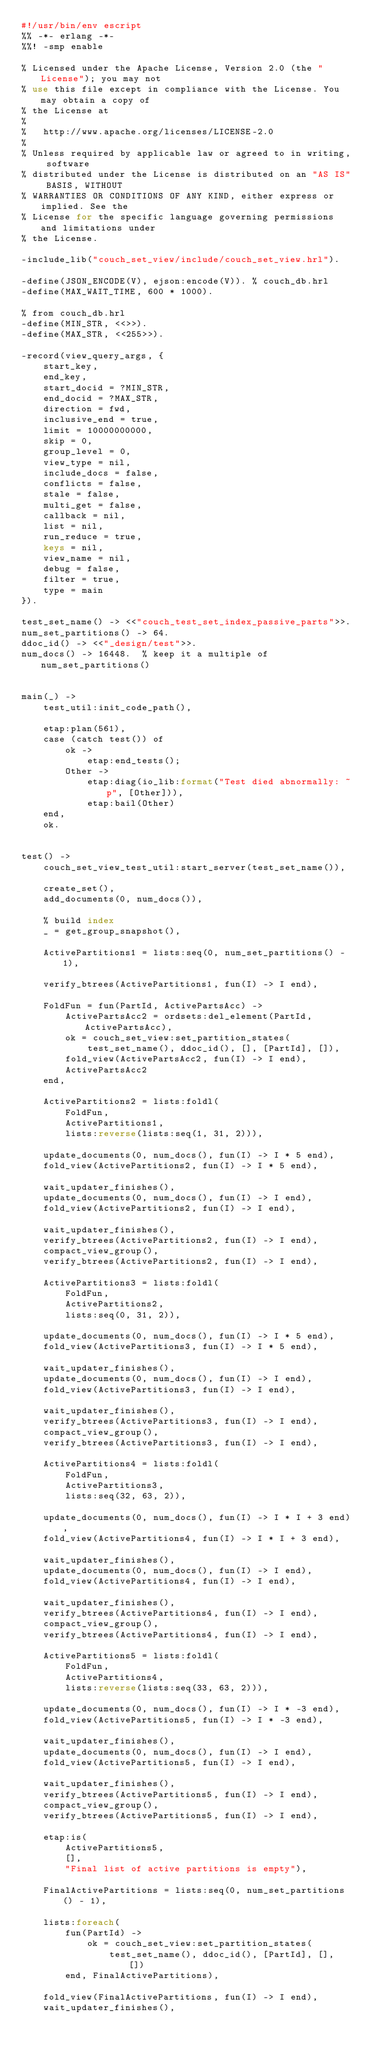<code> <loc_0><loc_0><loc_500><loc_500><_Perl_>#!/usr/bin/env escript
%% -*- erlang -*-
%%! -smp enable

% Licensed under the Apache License, Version 2.0 (the "License"); you may not
% use this file except in compliance with the License. You may obtain a copy of
% the License at
%
%   http://www.apache.org/licenses/LICENSE-2.0
%
% Unless required by applicable law or agreed to in writing, software
% distributed under the License is distributed on an "AS IS" BASIS, WITHOUT
% WARRANTIES OR CONDITIONS OF ANY KIND, either express or implied. See the
% License for the specific language governing permissions and limitations under
% the License.

-include_lib("couch_set_view/include/couch_set_view.hrl").

-define(JSON_ENCODE(V), ejson:encode(V)). % couch_db.hrl
-define(MAX_WAIT_TIME, 600 * 1000).

% from couch_db.hrl
-define(MIN_STR, <<>>).
-define(MAX_STR, <<255>>).

-record(view_query_args, {
    start_key,
    end_key,
    start_docid = ?MIN_STR,
    end_docid = ?MAX_STR,
    direction = fwd,
    inclusive_end = true,
    limit = 10000000000,
    skip = 0,
    group_level = 0,
    view_type = nil,
    include_docs = false,
    conflicts = false,
    stale = false,
    multi_get = false,
    callback = nil,
    list = nil,
    run_reduce = true,
    keys = nil,
    view_name = nil,
    debug = false,
    filter = true,
    type = main
}).

test_set_name() -> <<"couch_test_set_index_passive_parts">>.
num_set_partitions() -> 64.
ddoc_id() -> <<"_design/test">>.
num_docs() -> 16448.  % keep it a multiple of num_set_partitions()


main(_) ->
    test_util:init_code_path(),

    etap:plan(561),
    case (catch test()) of
        ok ->
            etap:end_tests();
        Other ->
            etap:diag(io_lib:format("Test died abnormally: ~p", [Other])),
            etap:bail(Other)
    end,
    ok.


test() ->
    couch_set_view_test_util:start_server(test_set_name()),

    create_set(),
    add_documents(0, num_docs()),

    % build index
    _ = get_group_snapshot(),

    ActivePartitions1 = lists:seq(0, num_set_partitions() - 1),

    verify_btrees(ActivePartitions1, fun(I) -> I end),

    FoldFun = fun(PartId, ActivePartsAcc) ->
        ActivePartsAcc2 = ordsets:del_element(PartId, ActivePartsAcc),
        ok = couch_set_view:set_partition_states(
            test_set_name(), ddoc_id(), [], [PartId], []),
        fold_view(ActivePartsAcc2, fun(I) -> I end),
        ActivePartsAcc2
    end,

    ActivePartitions2 = lists:foldl(
        FoldFun,
        ActivePartitions1,
        lists:reverse(lists:seq(1, 31, 2))),

    update_documents(0, num_docs(), fun(I) -> I * 5 end),
    fold_view(ActivePartitions2, fun(I) -> I * 5 end),

    wait_updater_finishes(),
    update_documents(0, num_docs(), fun(I) -> I end),
    fold_view(ActivePartitions2, fun(I) -> I end),

    wait_updater_finishes(),
    verify_btrees(ActivePartitions2, fun(I) -> I end),
    compact_view_group(),
    verify_btrees(ActivePartitions2, fun(I) -> I end),

    ActivePartitions3 = lists:foldl(
        FoldFun,
        ActivePartitions2,
        lists:seq(0, 31, 2)),

    update_documents(0, num_docs(), fun(I) -> I * 5 end),
    fold_view(ActivePartitions3, fun(I) -> I * 5 end),

    wait_updater_finishes(),
    update_documents(0, num_docs(), fun(I) -> I end),
    fold_view(ActivePartitions3, fun(I) -> I end),

    wait_updater_finishes(),
    verify_btrees(ActivePartitions3, fun(I) -> I end),
    compact_view_group(),
    verify_btrees(ActivePartitions3, fun(I) -> I end),

    ActivePartitions4 = lists:foldl(
        FoldFun,
        ActivePartitions3,
        lists:seq(32, 63, 2)),

    update_documents(0, num_docs(), fun(I) -> I * I + 3 end),
    fold_view(ActivePartitions4, fun(I) -> I * I + 3 end),

    wait_updater_finishes(),
    update_documents(0, num_docs(), fun(I) -> I end),
    fold_view(ActivePartitions4, fun(I) -> I end),

    wait_updater_finishes(),
    verify_btrees(ActivePartitions4, fun(I) -> I end),
    compact_view_group(),
    verify_btrees(ActivePartitions4, fun(I) -> I end),

    ActivePartitions5 = lists:foldl(
        FoldFun,
        ActivePartitions4,
        lists:reverse(lists:seq(33, 63, 2))),

    update_documents(0, num_docs(), fun(I) -> I * -3 end),
    fold_view(ActivePartitions5, fun(I) -> I * -3 end),

    wait_updater_finishes(),
    update_documents(0, num_docs(), fun(I) -> I end),
    fold_view(ActivePartitions5, fun(I) -> I end),

    wait_updater_finishes(),
    verify_btrees(ActivePartitions5, fun(I) -> I end),
    compact_view_group(),
    verify_btrees(ActivePartitions5, fun(I) -> I end),

    etap:is(
        ActivePartitions5,
        [],
        "Final list of active partitions is empty"),

    FinalActivePartitions = lists:seq(0, num_set_partitions() - 1),

    lists:foreach(
        fun(PartId) ->
            ok = couch_set_view:set_partition_states(
                test_set_name(), ddoc_id(), [PartId], [], [])
        end, FinalActivePartitions),

    fold_view(FinalActivePartitions, fun(I) -> I end),
    wait_updater_finishes(),</code> 